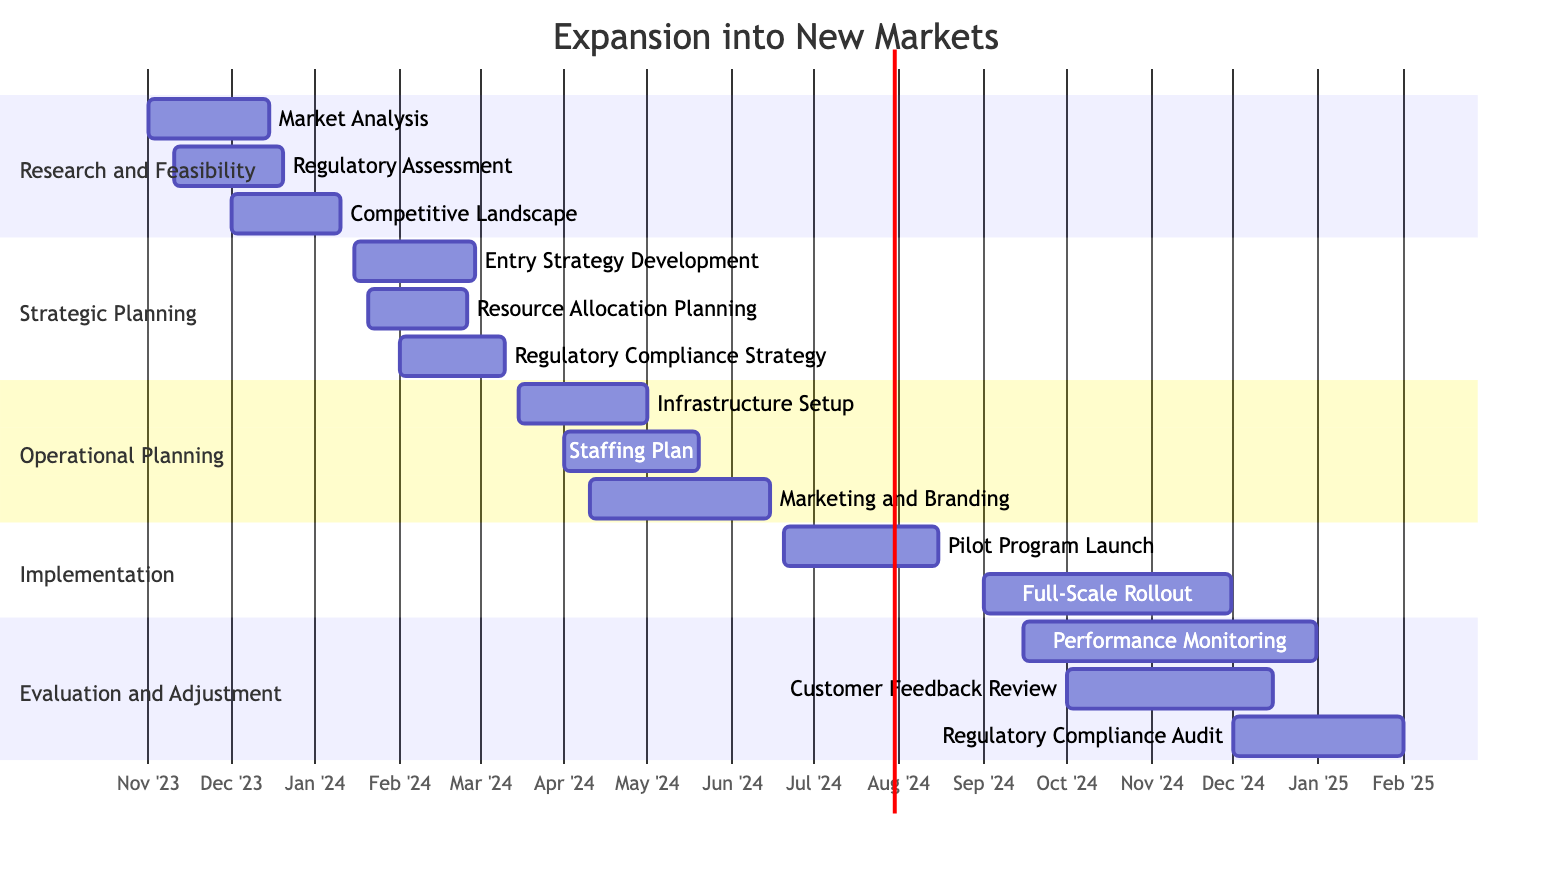What is the duration of the "Market Analysis" task? The "Market Analysis" task starts on November 1, 2023, and ends on December 15, 2023. To find the duration, calculate the total days between these two dates, which is 45 days.
Answer: 45 days How many phases are there in the project? The Gantt chart shows a total of five distinct phases: Research and Feasibility, Strategic Planning, Operational Planning, Implementation, and Evaluation and Adjustment. Therefore, the count of phases is five.
Answer: 5 Which task in the "Operational Planning" phase has the earliest start date? The tasks listed under the "Operational Planning" phase are Infrastructure Setup (starts March 15, 2024), Staffing Plan (starts April 1, 2024), and Marketing and Branding (starts April 10, 2024). The earliest start date from these is March 15, 2024, associated with Infrastructure Setup.
Answer: Infrastructure Setup How long does the "Regulatory Compliance Audit" take? The "Regulatory Compliance Audit" starts on December 1, 2024, and ends on February 1, 2025. The duration can be calculated by counting the days between the start and end dates, which is 62 days.
Answer: 62 days Which task overlaps with the "Pilot Program Launch"? The "Pilot Program Launch" occurs from June 20, 2024, to August 15, 2024. Looking at tasks scheduled during these dates, the "Performance Monitoring" task starts on September 15, 2024, and thus does not overlap. The only task that overlaps partially is "Full-Scale Rollout," which starts September 1, 2024.
Answer: Full-Scale Rollout How many tasks are planned in total? To find the total number of tasks, count all tasks across each phase. There are three tasks in Research and Feasibility, three in Strategic Planning, three in Operational Planning, two in Implementation, and three in Evaluation and Adjustment, resulting in a total of 14 tasks.
Answer: 14 What is the last task in the project timeline? The last task scheduled in the project timeline is the "Regulatory Compliance Audit," which starts on December 1, 2024, and ends on February 1, 2025, marking it as the concluding task of the entire project.
Answer: Regulatory Compliance Audit Which phase contains the task "Resource Allocation Planning"? The "Resource Allocation Planning" task starts on January 20, 2024, and ends on February 25, 2024. Referring to the Gantt chart, this task is part of the "Strategic Planning" phase.
Answer: Strategic Planning 